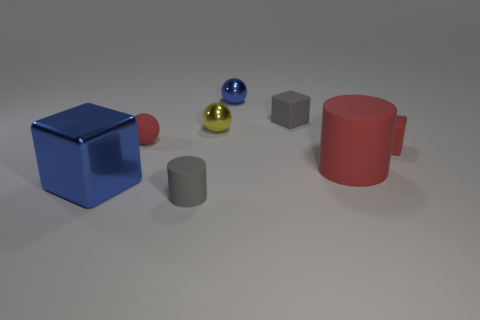Subtract all small red matte spheres. How many spheres are left? 2 Subtract 3 blocks. How many blocks are left? 0 Subtract all blue cubes. Subtract all red balls. How many cubes are left? 2 Subtract all purple spheres. How many red cylinders are left? 1 Subtract all small brown rubber things. Subtract all big rubber cylinders. How many objects are left? 7 Add 5 big red cylinders. How many big red cylinders are left? 6 Add 2 large things. How many large things exist? 4 Add 1 big cyan matte cubes. How many objects exist? 9 Subtract all red balls. How many balls are left? 2 Subtract 0 blue cylinders. How many objects are left? 8 